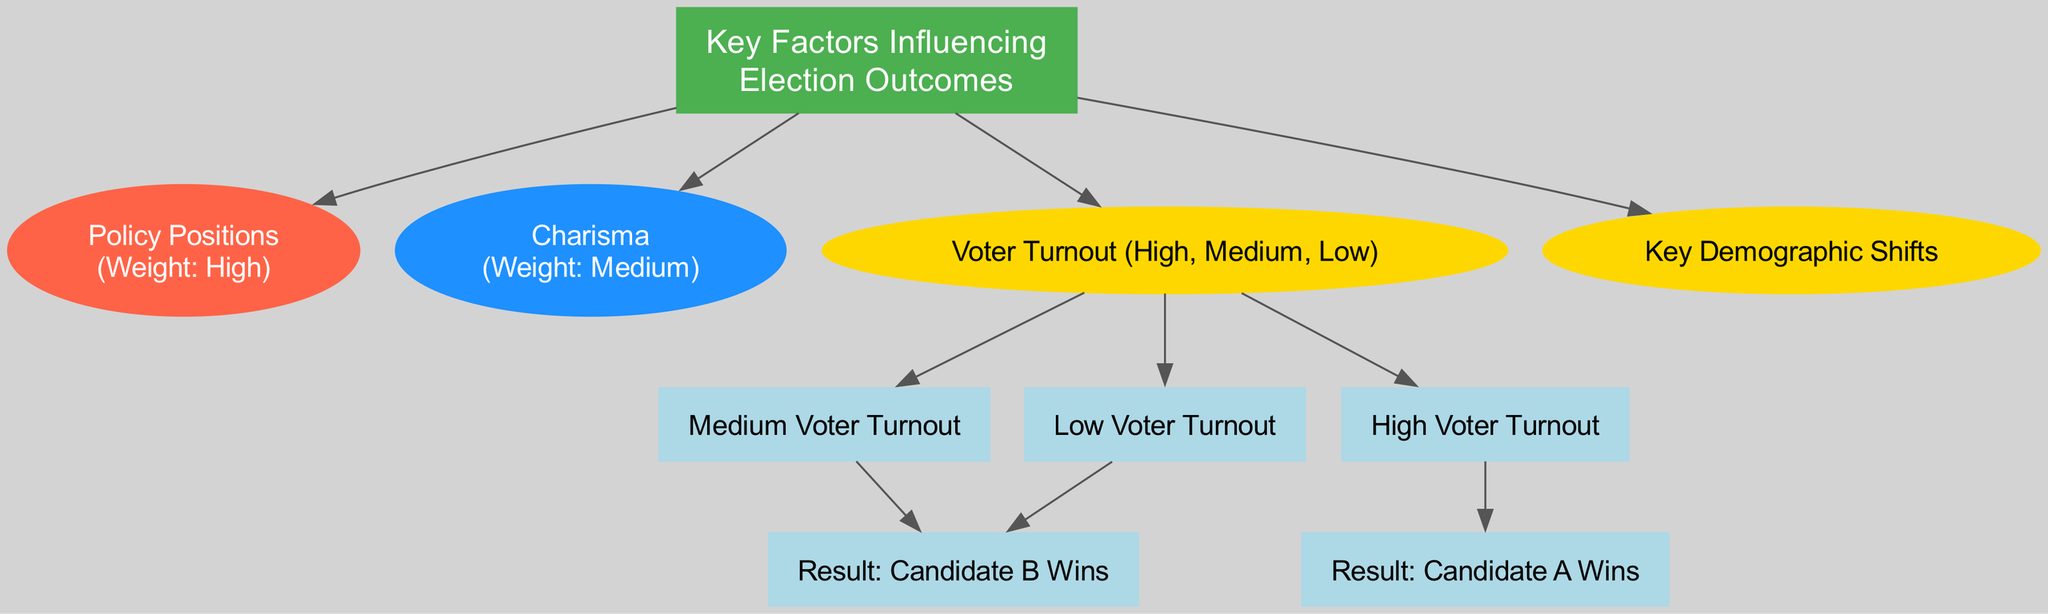What are the key factors influencing election outcomes? The diagram lists "Policy Positions," "Charisma," "Voter Turnout," and "Key Demographic Shifts" under the "Key Factors Influencing Election Outcomes" rectangle as the main elements.
Answer: Policy Positions, Charisma, Voter Turnout, Key Demographic Shifts What is the weight assigned to "Policy Positions"? The flow chart specifies that the weight for "Policy Positions" is categorized as "High," indicating its significant importance in influencing election outcomes.
Answer: High Which candidate is likely to win with high voter turnout? The flow chart shows a direct connection from "High Voter Turnout" to "Result: Candidate A Wins," indicating that under such conditions, Candidate A is favored to win.
Answer: Candidate A Wins What outcome is predicted for low voter turnout? According to the diagram, "Low Voter Turnout" leads to "Result: Candidate B Wins," suggesting that low turnout benefits Candidate B in this model.
Answer: Candidate B Wins How many types of voter turnout are represented? The diagram includes three categories under "Voter Turnout": High, Medium, and Low. Thus, the count of voter turnout types shown is three.
Answer: Three Which factor has the highest weight according to the flowchart? The flowchart clearly indicates that "Policy Positions" is given a "High" weight, which is more than "Charisma," which has a "Medium" weight.
Answer: Policy Positions What happens when voter turnout is medium? The flowchart illustrates that "Medium Voter Turnout" leads to "Result: Candidate B Wins," indicating that this level of turnout favors Candidate B.
Answer: Candidate B Wins What is the relationship between charisma and election outcomes? In the flowchart, "Charisma" influences election outcomes as a contributing factor with a "Medium" weight, but it is not directly linked to any specific results, unlike policies.
Answer: Medium weight influence Which candidate wins if voter turnout is low or medium? The diagram shows that both "Low Voter Turnout" and "Medium Voter Turnout" points lead to "Result: Candidate B Wins," indicating that both conditions favor Candidate B.
Answer: Candidate B Wins 